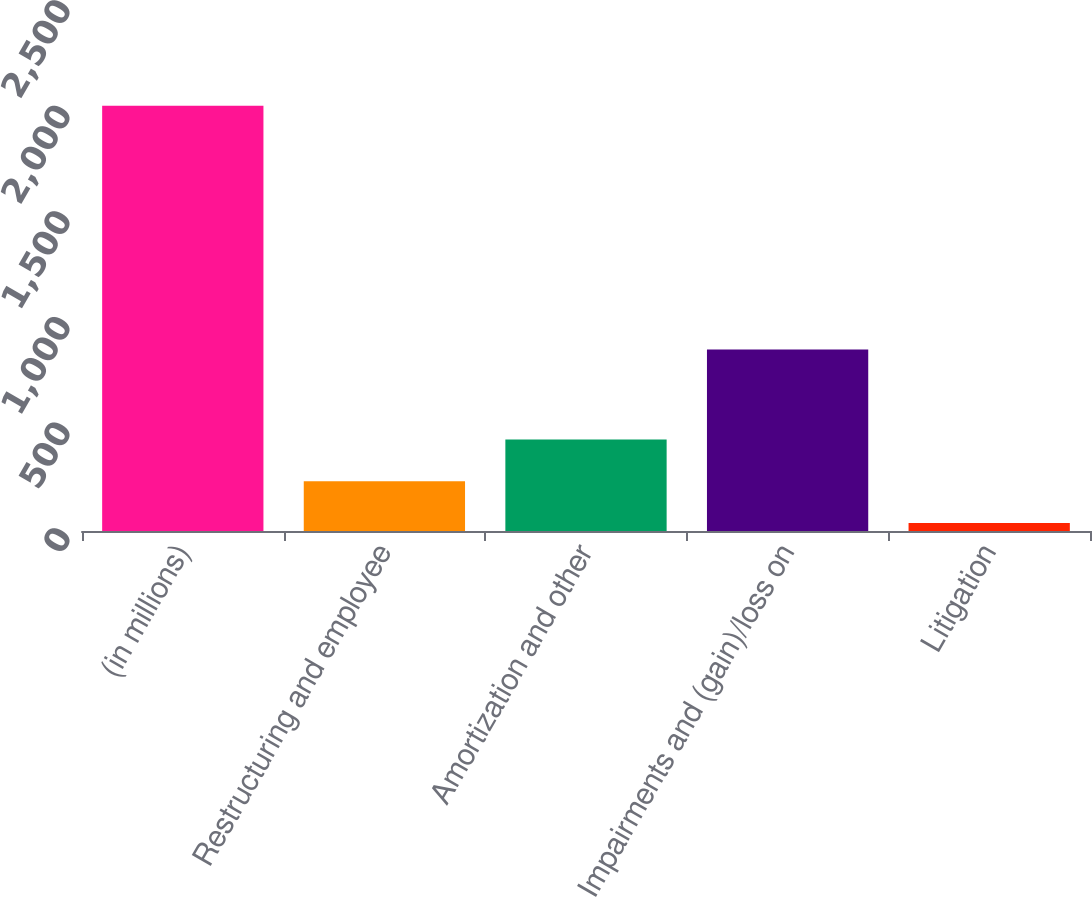Convert chart. <chart><loc_0><loc_0><loc_500><loc_500><bar_chart><fcel>(in millions)<fcel>Restructuring and employee<fcel>Amortization and other<fcel>Impairments and (gain)/loss on<fcel>Litigation<nl><fcel>2013<fcel>235.5<fcel>433<fcel>859<fcel>38<nl></chart> 